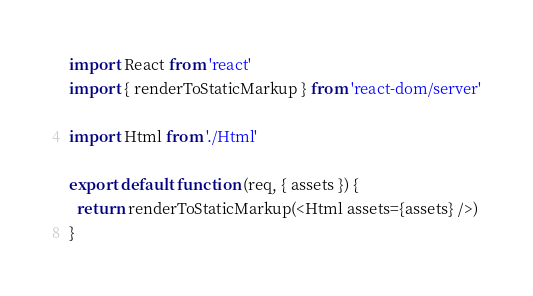Convert code to text. <code><loc_0><loc_0><loc_500><loc_500><_JavaScript_>import React from 'react'
import { renderToStaticMarkup } from 'react-dom/server'

import Html from './Html'

export default function (req, { assets }) {
  return renderToStaticMarkup(<Html assets={assets} />)
}
</code> 